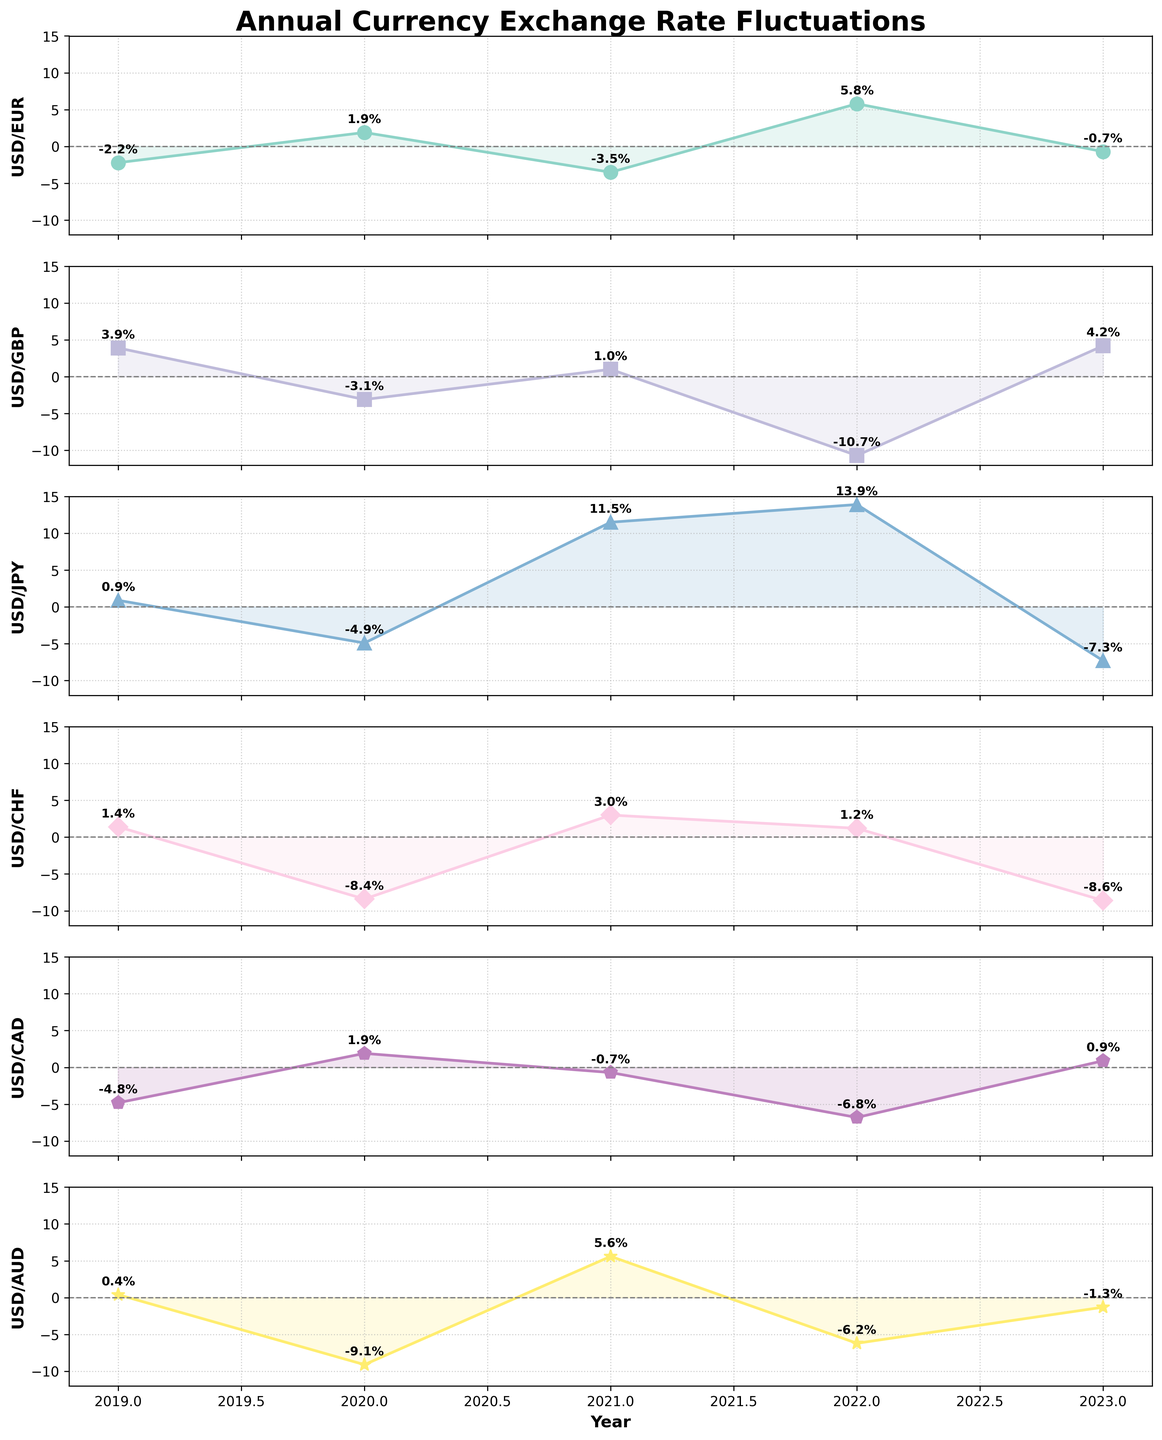What is the overall trend for USD/EUR from 2019 to 2023? USD/EUR starts at -2.2% in 2019, increases to 1.9% in 2020, declines to -3.5% in 2021, rises sharply to 5.8% in 2022, and drops to -0.7% in 2023. The trend shows fluctuations with no clear overall direction.
Answer: Fluctuates Which currency pair shows the largest decline in a single year? USD/GBP shows the largest decline in 2022 with a value of -10.7%.
Answer: USD/GBP in 2022 What is the average fluctuation rate for USD/JPY over the 5 years? The values for USD/JPY are 0.9, -4.9, 11.5, 13.9, and -7.3. Summing these values gives 14.1, and dividing by 5 gives an average of 2.82%.
Answer: 2.82% How did the USD/CHF rate change from 2021 to 2022? The USD/CHF rate decreased from 3.0% in 2021 to 1.2% in 2022. This is a decline of 1.8%.
Answer: Decreased by 1.8% Which currency had the largest positive fluctuation in any year? USD/JPY had the largest positive fluctuation with a value of 13.9% in 2022.
Answer: USD/JPY in 2022 What is the largest annual percentage decrease seen in USD/CHF over this period? USD/CHF shows a decrease of -8.4% in 2020 and -8.6% in 2023. The largest annual percentage decrease is -8.6% in 2023.
Answer: -8.6% in 2023 How does the fluctuation of USD/CAD in 2022 compare to 2023? USD/CAD has a fluctuation of -6.8% in 2022 and 0.9% in 2023. The fluctuation rate improves by 7.7 percentage points from 2022 to 2023.
Answer: Improved by 7.7% Which currencies experienced a negative fluctuation trend from 2021 to 2023? USD/JPY and USD/CHF experienced a negative trend from 2021 to 2023, declining from 11.5% to -7.3% and from 3.0% to -8.6%, respectively.
Answer: USD/JPY and USD/CHF What was the fluctuation rate of USD/AUD in 2020, and how does it compare to 2021? The fluctuation rate of USD/AUD in 2020 was -9.1%, whereas in 2021 it was 5.6%. There was an increase of 14.7 percentage points from 2020 to 2021.
Answer: Increased by 14.7% Which year has the sharpest relative increase and for which currency? USD/EUR has the sharpest relative increase from -3.5% in 2021 to 5.8% in 2022, an increase of 9.3 percentage points.
Answer: USD/EUR from 2021 to 2022 